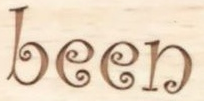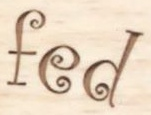What words can you see in these images in sequence, separated by a semicolon? been; fed 